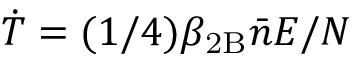<formula> <loc_0><loc_0><loc_500><loc_500>\dot { T } = ( 1 / 4 ) \beta _ { 2 B } \bar { n } E / N</formula> 